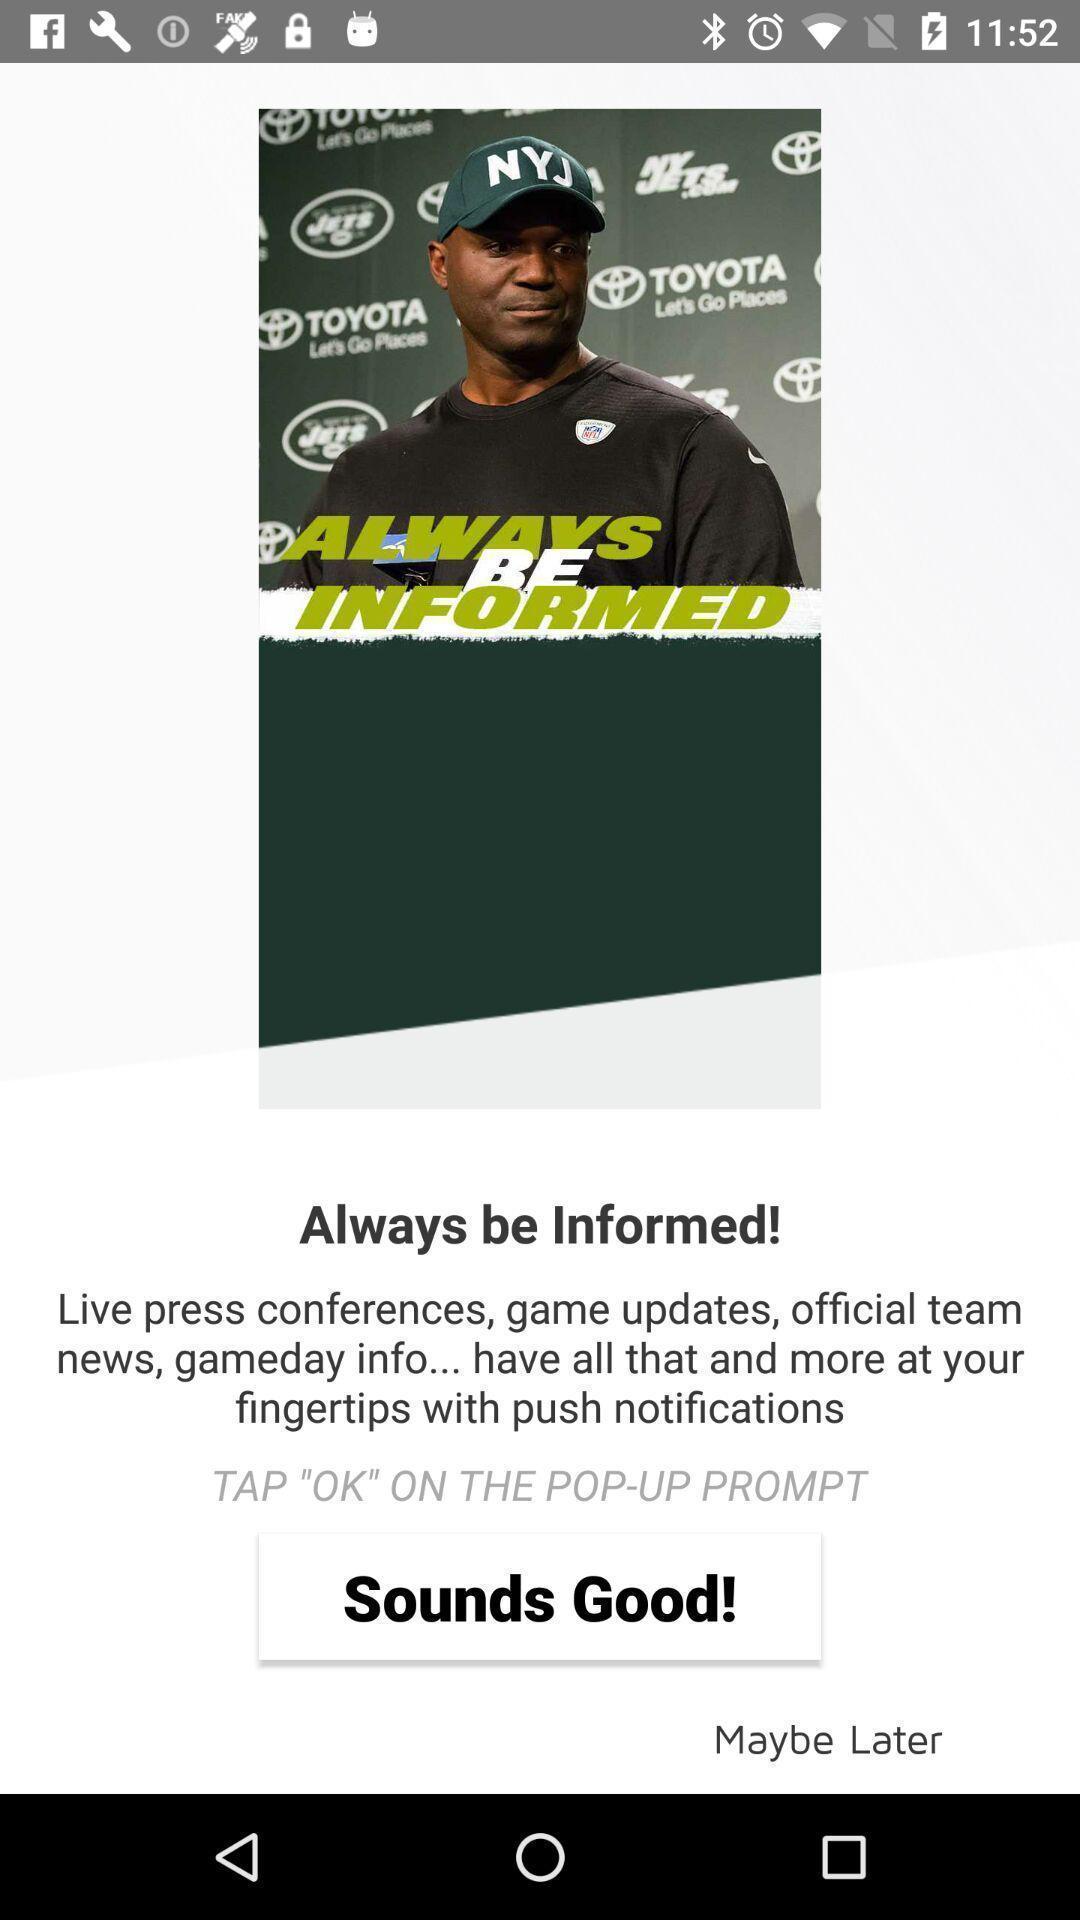Explain what's happening in this screen capture. Page of always be informed. 